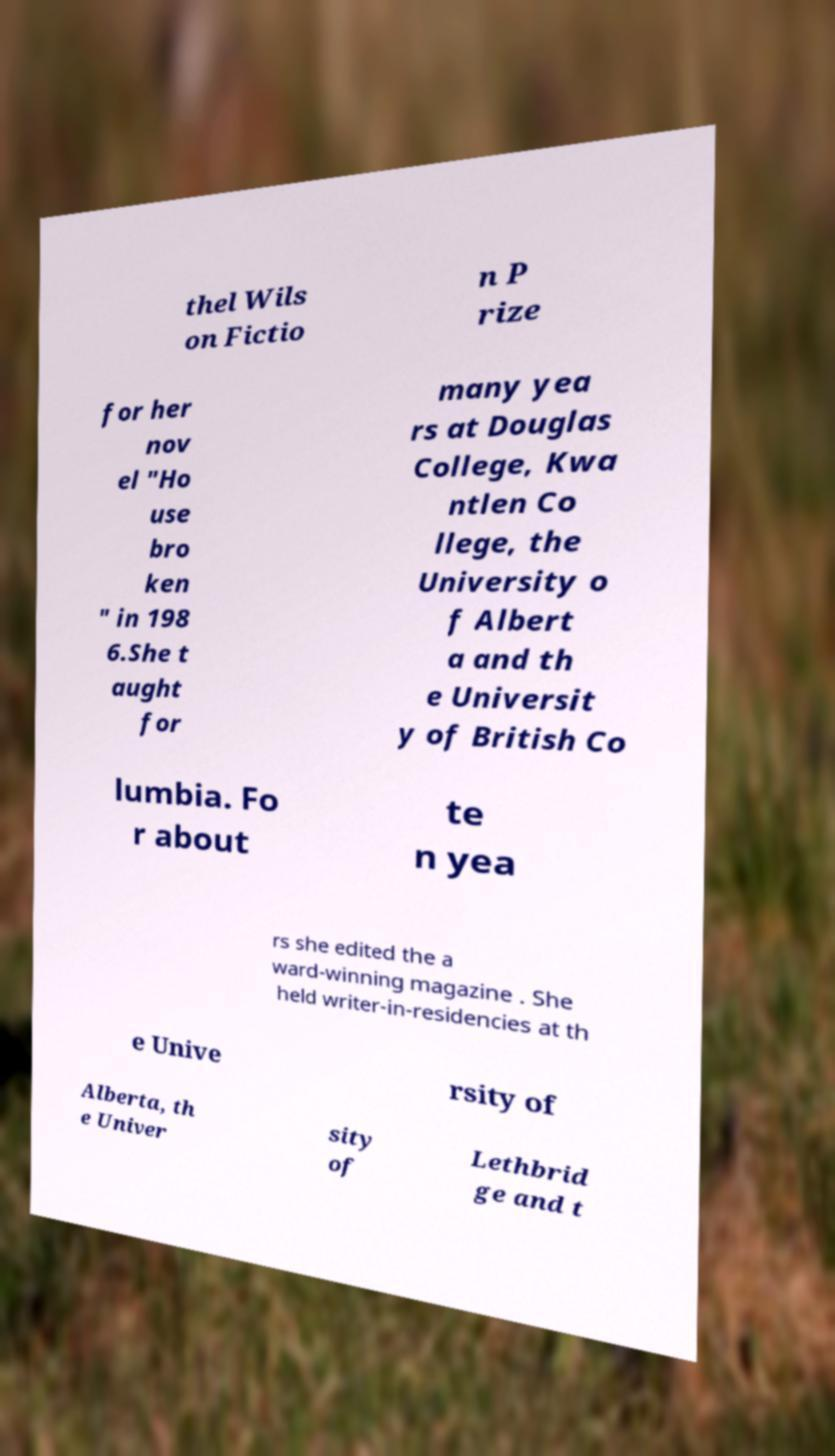What messages or text are displayed in this image? I need them in a readable, typed format. thel Wils on Fictio n P rize for her nov el "Ho use bro ken " in 198 6.She t aught for many yea rs at Douglas College, Kwa ntlen Co llege, the University o f Albert a and th e Universit y of British Co lumbia. Fo r about te n yea rs she edited the a ward-winning magazine . She held writer-in-residencies at th e Unive rsity of Alberta, th e Univer sity of Lethbrid ge and t 